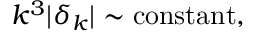Convert formula to latex. <formula><loc_0><loc_0><loc_500><loc_500>k ^ { 3 } | \delta _ { k } | \sim c o n s t a n t ,</formula> 